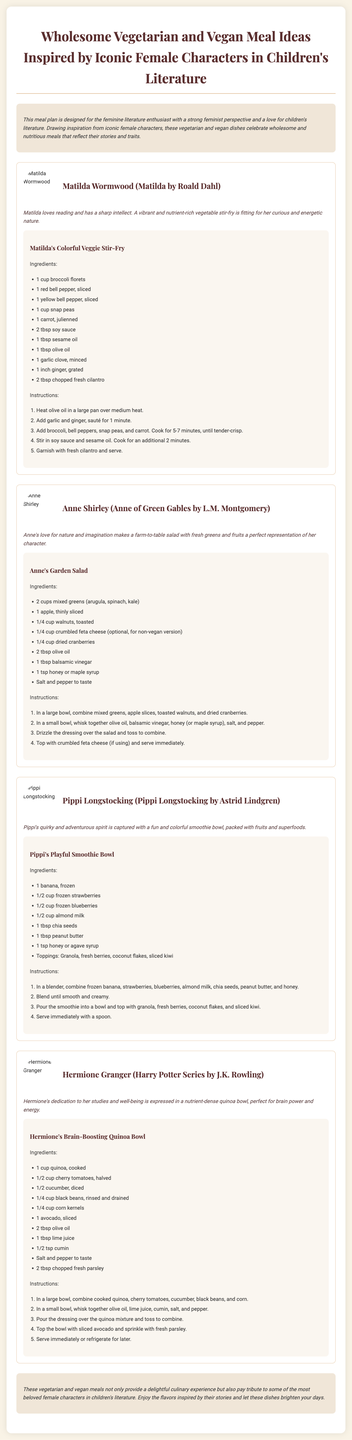What is the title of the meal plan? The title of the meal plan is presented at the top of the document.
Answer: Wholesome Vegetarian and Vegan Meal Ideas Inspired by Iconic Female Characters in Children's Literature Who is the first character featured? The first character listed in the meal plan is mentioned as part of a recipe section.
Answer: Matilda Wormwood What is the primary ingredient in Matilda's Colorful Veggie Stir-Fry? The primary components are listed in the ingredients section for Matilda's dish.
Answer: Broccoli florets How many meals are included in the meal plan? The document details each meal in separate sections, and the number of meals can be counted.
Answer: Four Which character inspires a garden salad? The character associated with the garden salad is referenced in the meal section.
Answer: Anne Shirley What type of dressing is used in Anne's Garden Salad? The kind of dressing is specifically mentioned in the ingredients list for Anne’s dish.
Answer: Olive oil and balsamic vinegar What is the main focus of Hermione's Brain-Boosting Quinoa Bowl? The meal's purpose is articulated in the description of Hermione's dish.
Answer: Nutrient-dense What are the toppings for Pippi's Playful Smoothie Bowl? Toppings are listed in the ingredients section for Pippi's dish.
Answer: Granola, fresh berries, coconut flakes, sliced kiwi What is the significance of the meal plan's design? The introduction highlights the intended audience and purpose of the meal plan.
Answer: Feminine literature and feminist perspective 